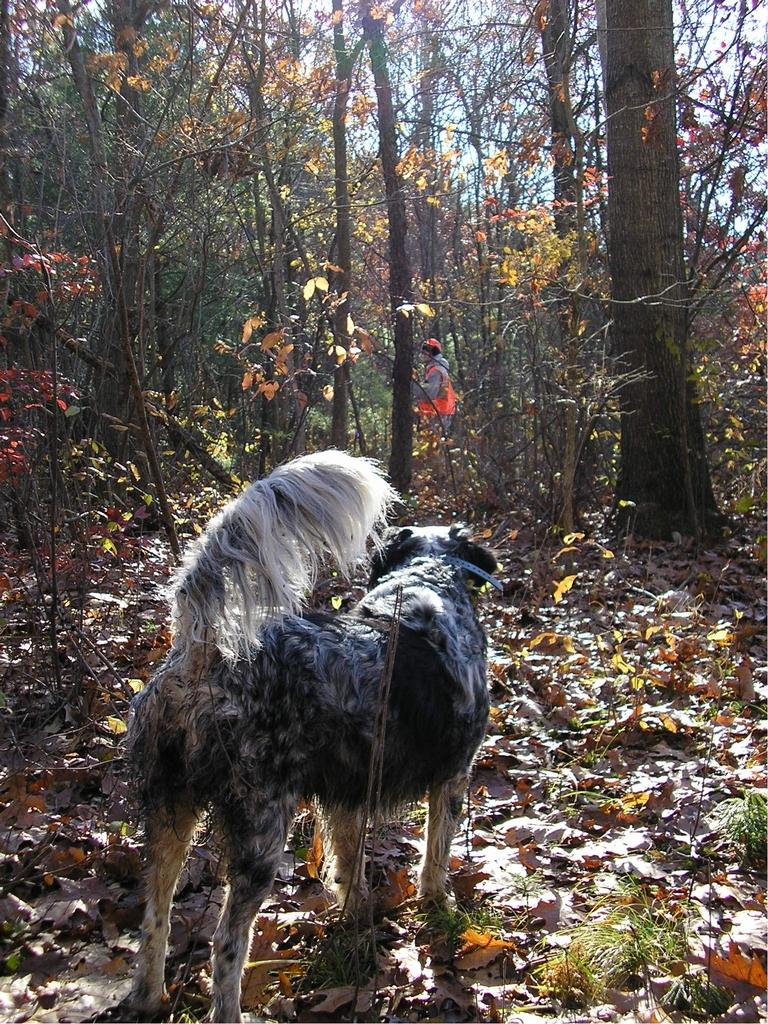What type of animal is present in the image? There is a dog in the image. What can be seen at the bottom of the image? There are dry leaves and plants at the bottom of the image. What is visible in the background of the image? There are trees and the sky visible in the background of the image. Can you describe the person in the background of the image? There is a person standing in the background of the image. What shape does the dog draw in the leaves with its paws? The image does not show the dog drawing any shapes in the leaves with its paws. 